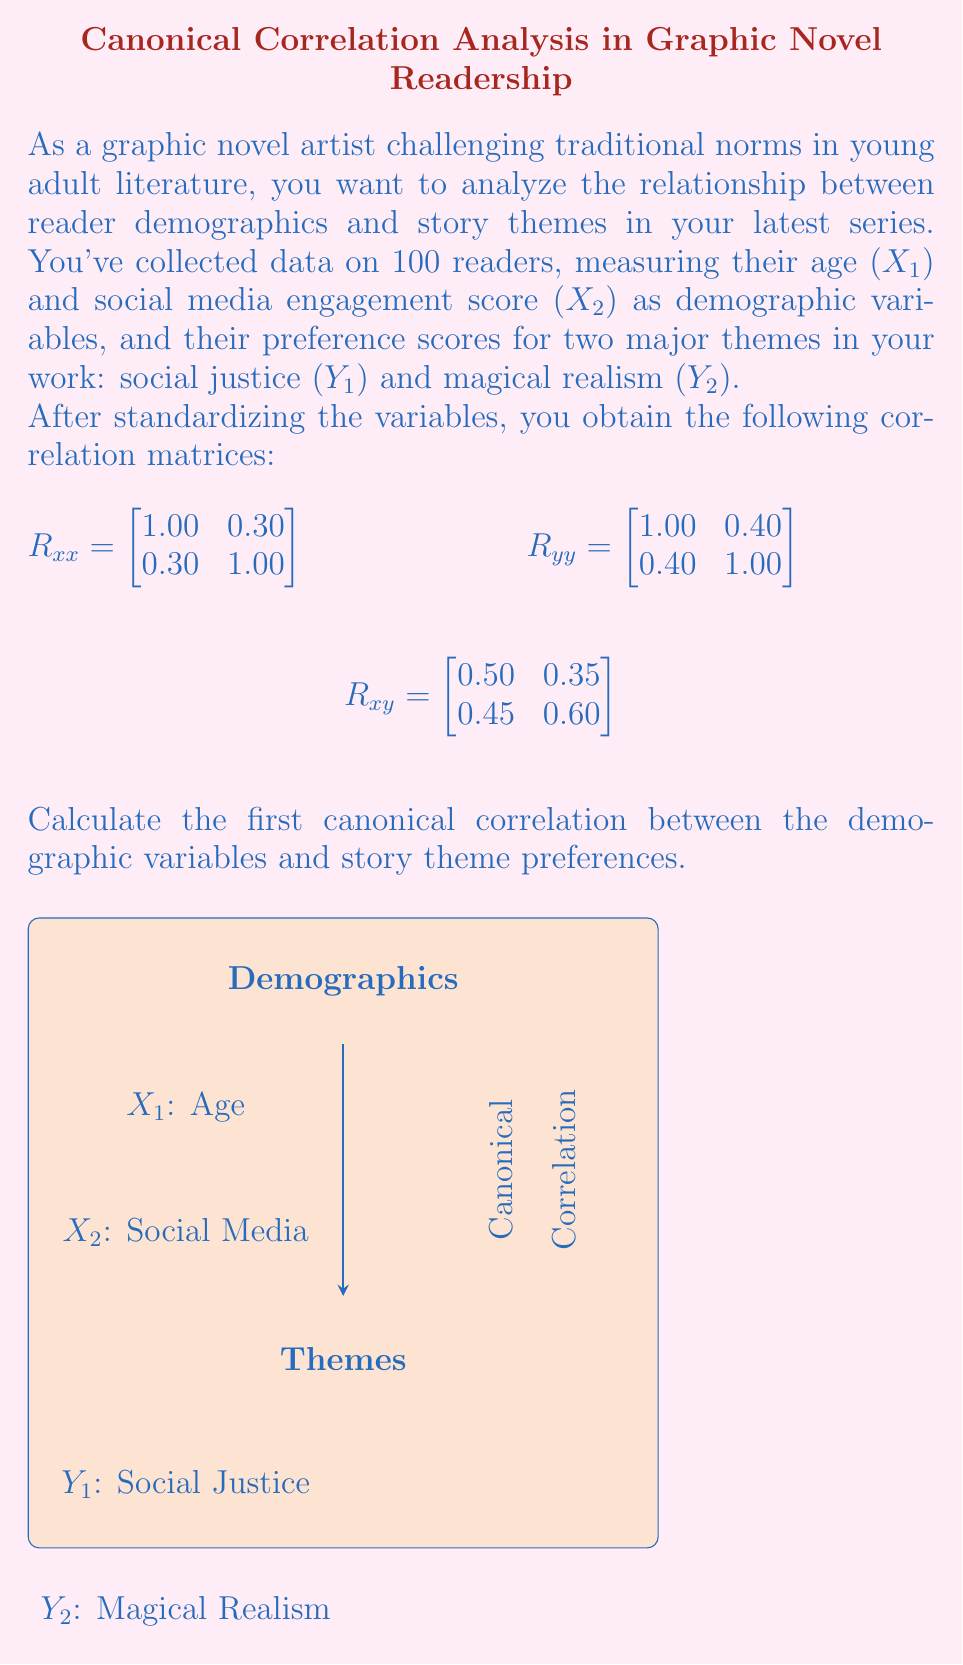Can you answer this question? To find the first canonical correlation, we need to follow these steps:

1) First, we need to calculate the matrices $R_{xx}^{-1}$ and $R_{yy}^{-1}$:

   $$R_{xx}^{-1} = \frac{1}{1-0.3^2}\begin{bmatrix}
   1.00 & -0.30 \\
   -0.30 & 1.00
   \end{bmatrix} = \begin{bmatrix}
   1.10 & -0.33 \\
   -0.33 & 1.10
   \end{bmatrix}$$

   $$R_{yy}^{-1} = \frac{1}{1-0.4^2}\begin{bmatrix}
   1.00 & -0.40 \\
   -0.40 & 1.00
   \end{bmatrix} = \begin{bmatrix}
   1.19 & -0.48 \\
   -0.48 & 1.19
   \end{bmatrix}$$

2) Next, we compute the matrix $R_{xx}^{-1}R_{xy}R_{yy}^{-1}R_{yx}$:

   $$R_{xx}^{-1}R_{xy} = \begin{bmatrix}
   0.385 & 0.255 \\
   0.330 & 0.495
   \end{bmatrix}$$

   $$R_{xx}^{-1}R_{xy}R_{yy}^{-1} = \begin{bmatrix}
   0.3461 & -0.0031 \\
   0.2097 & 0.4913
   \end{bmatrix}$$

   $$R_{xx}^{-1}R_{xy}R_{yy}^{-1}R_{yx} = \begin{bmatrix}
   0.1723 & 0.2067 \\
   0.2067 & 0.3984
   \end{bmatrix}$$

3) The eigenvalues of this matrix are the squared canonical correlations. We can find them by solving the characteristic equation:

   $$\det(R_{xx}^{-1}R_{xy}R_{yy}^{-1}R_{yx} - \lambda I) = 0$$

   $$(0.1723 - \lambda)(0.3984 - \lambda) - 0.2067^2 = 0$$

   $$\lambda^2 - 0.5707\lambda + 0.0257 = 0$$

4) Solving this quadratic equation:

   $$\lambda = \frac{0.5707 \pm \sqrt{0.5707^2 - 4(0.0257)}}{2}$$

   $$\lambda_1 = 0.5170, \lambda_2 = 0.0537$$

5) The canonical correlations are the square roots of these eigenvalues. The first (largest) canonical correlation is:

   $$r_1 = \sqrt{0.5170} = 0.7190$$
Answer: $0.7190$ 